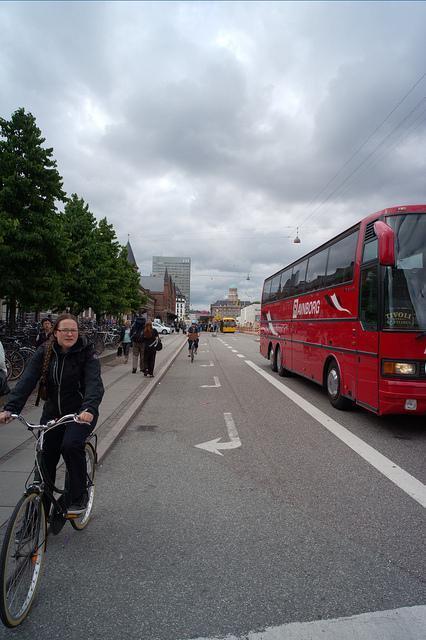How many bikes are there?
Give a very brief answer. 1. How many wheels do the vehicles on the left have?
Give a very brief answer. 2. How many people are on the bike?
Give a very brief answer. 1. How many horses are shown?
Give a very brief answer. 0. 